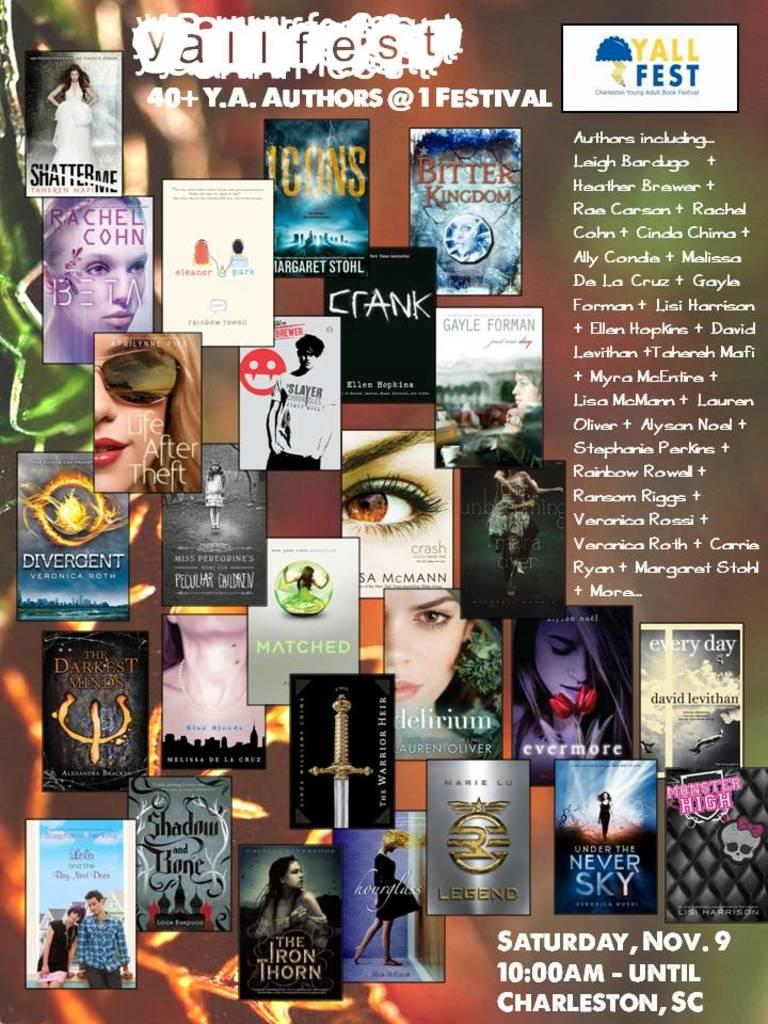<image>
Present a compact description of the photo's key features. a poster that says 'yallfest 40+ y.a.authors @ 1 festival' on it 